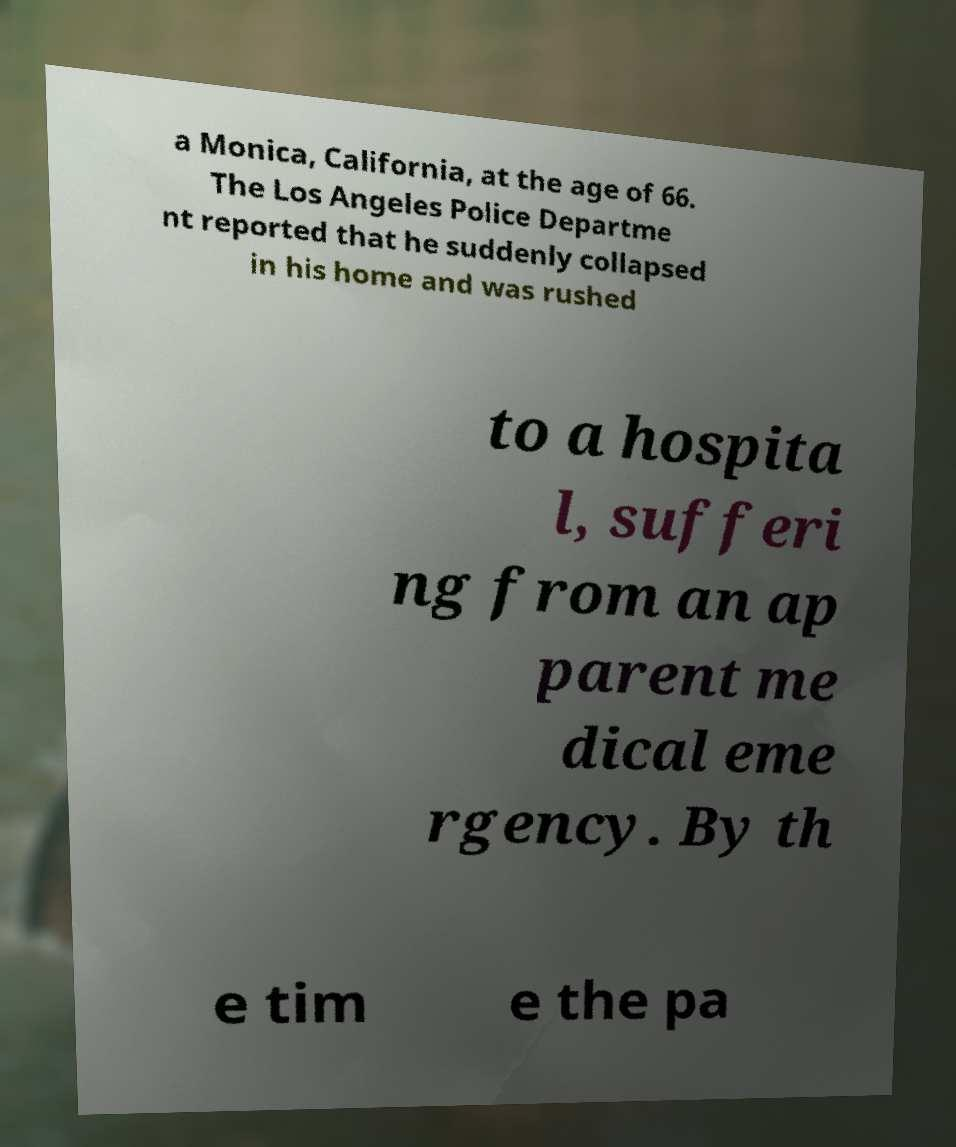Could you extract and type out the text from this image? a Monica, California, at the age of 66. The Los Angeles Police Departme nt reported that he suddenly collapsed in his home and was rushed to a hospita l, sufferi ng from an ap parent me dical eme rgency. By th e tim e the pa 